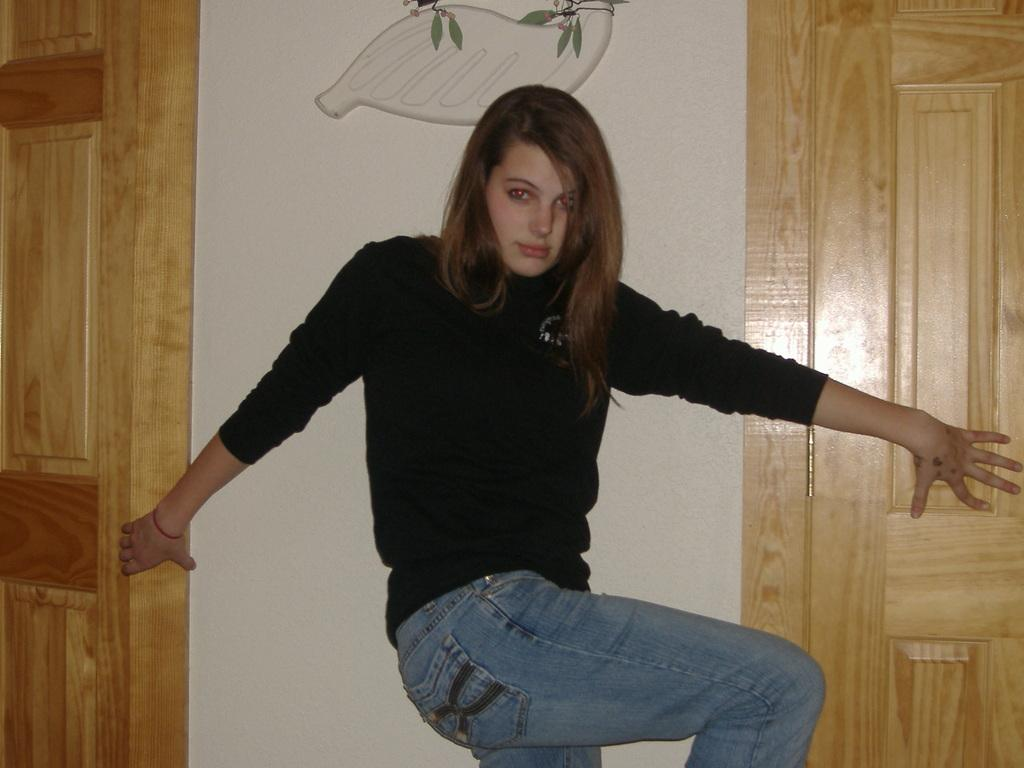Who is the main subject in the image? There is a woman in the image. What is the woman wearing? The woman is wearing a black T-shirt. What can be seen on both sides of the image? There are doors on the left side and the right side of the image. What is the woman doing in the image? The woman is holding the doors. What type of crate is visible in the image? There is no crate present in the image. What word is written on the doors in the image? The image does not show any words written on the doors. 